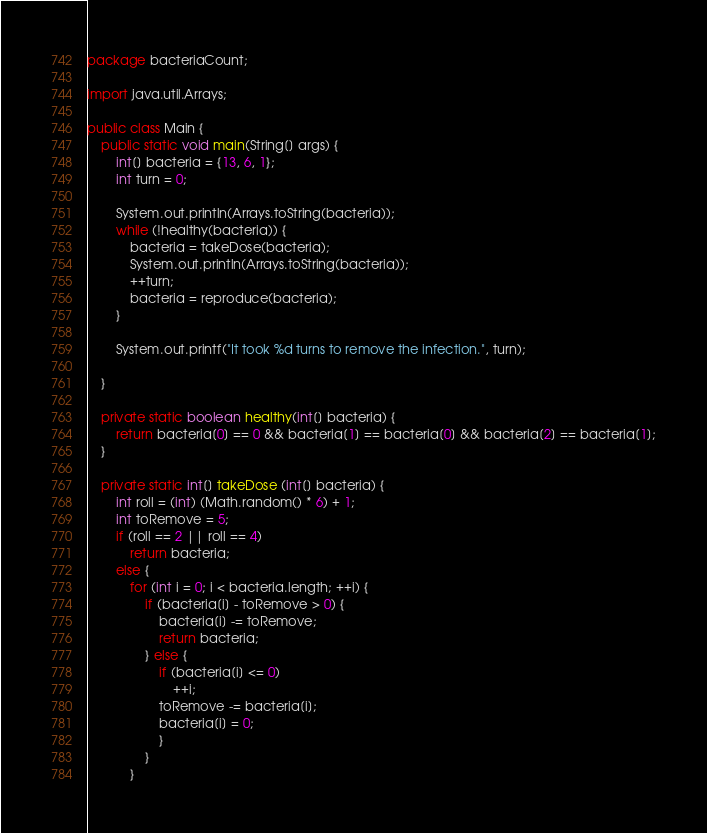<code> <loc_0><loc_0><loc_500><loc_500><_Java_>package bacteriaCount;

import java.util.Arrays;

public class Main {
    public static void main(String[] args) {
        int[] bacteria = {13, 6, 1};
        int turn = 0;

        System.out.println(Arrays.toString(bacteria));
        while (!healthy(bacteria)) {
            bacteria = takeDose(bacteria);
            System.out.println(Arrays.toString(bacteria));
            ++turn;
            bacteria = reproduce(bacteria);
        }

        System.out.printf("It took %d turns to remove the infection.", turn);

    }

    private static boolean healthy(int[] bacteria) {
        return bacteria[0] == 0 && bacteria[1] == bacteria[0] && bacteria[2] == bacteria[1];
    }

    private static int[] takeDose (int[] bacteria) {
        int roll = (int) (Math.random() * 6) + 1;
        int toRemove = 5;
        if (roll == 2 || roll == 4)
            return bacteria;
        else {
            for (int i = 0; i < bacteria.length; ++i) {
                if (bacteria[i] - toRemove > 0) {
                    bacteria[i] -= toRemove;
                    return bacteria;
                } else {
                    if (bacteria[i] <= 0)
                        ++i;
                    toRemove -= bacteria[i];
                    bacteria[i] = 0;
                    }
                }
            }
</code> 